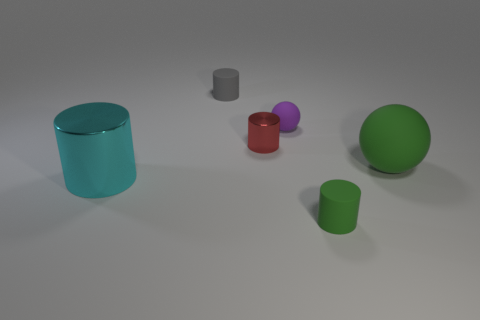Add 1 big things. How many objects exist? 7 Subtract all spheres. How many objects are left? 4 Add 2 green cylinders. How many green cylinders are left? 3 Add 4 balls. How many balls exist? 6 Subtract 0 yellow cylinders. How many objects are left? 6 Subtract all yellow shiny things. Subtract all purple rubber objects. How many objects are left? 5 